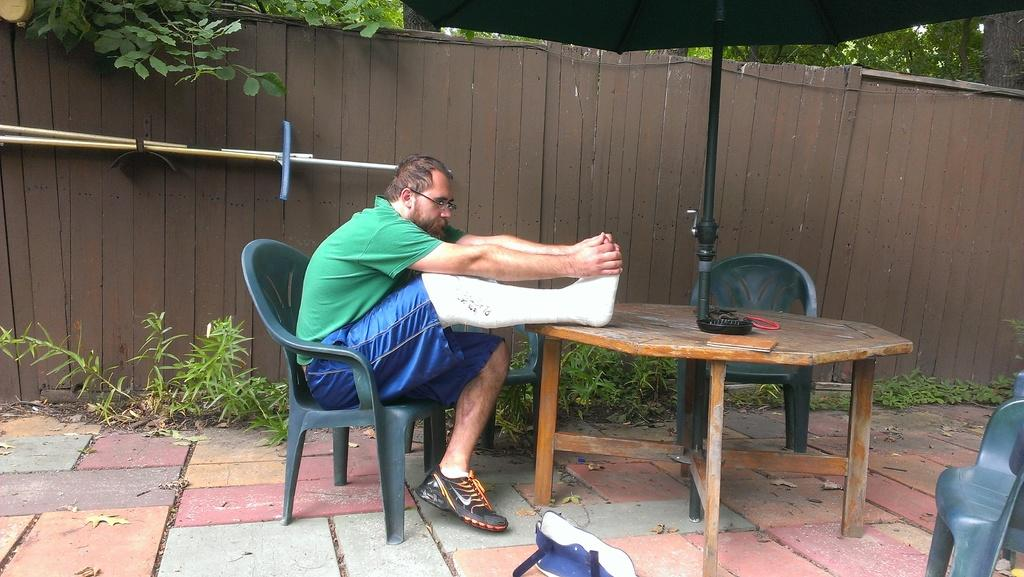Who is present in the image? There is a man in the image. What is the condition of the man's leg? The man has a broken leg. What is the man doing with his broken leg? The man is stretching his broken leg. What object can be seen in the image besides the man? There is a table in the image. What type of acoustics can be heard in the image? There is no information about acoustics or sounds in the image, so it cannot be determined. 